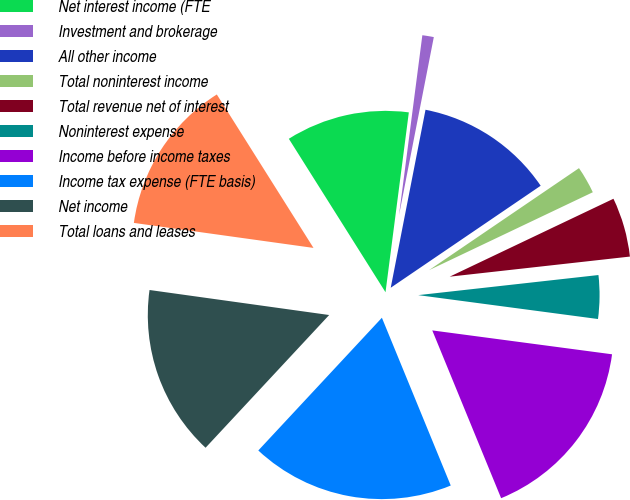<chart> <loc_0><loc_0><loc_500><loc_500><pie_chart><fcel>Net interest income (FTE<fcel>Investment and brokerage<fcel>All other income<fcel>Total noninterest income<fcel>Total revenue net of interest<fcel>Noninterest expense<fcel>Income before income taxes<fcel>Income tax expense (FTE basis)<fcel>Net income<fcel>Total loans and leases<nl><fcel>11.0%<fcel>1.02%<fcel>12.42%<fcel>2.44%<fcel>5.3%<fcel>3.87%<fcel>16.7%<fcel>18.13%<fcel>15.27%<fcel>13.85%<nl></chart> 